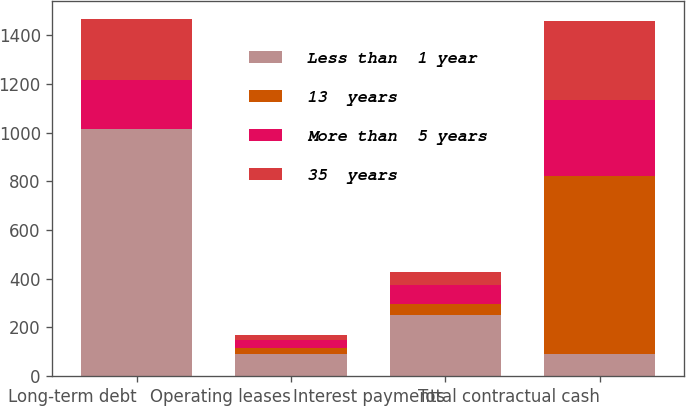Convert chart to OTSL. <chart><loc_0><loc_0><loc_500><loc_500><stacked_bar_chart><ecel><fcel>Long-term debt<fcel>Operating leases<fcel>Interest payments<fcel>Total contractual cash<nl><fcel>Less than  1 year<fcel>1013.5<fcel>92.3<fcel>252.7<fcel>92.3<nl><fcel>13  years<fcel>1.2<fcel>23.4<fcel>43.2<fcel>731.1<nl><fcel>More than  5 years<fcel>201.3<fcel>31.5<fcel>78.1<fcel>310.9<nl><fcel>35  years<fcel>251.5<fcel>19.8<fcel>53.7<fcel>325<nl></chart> 